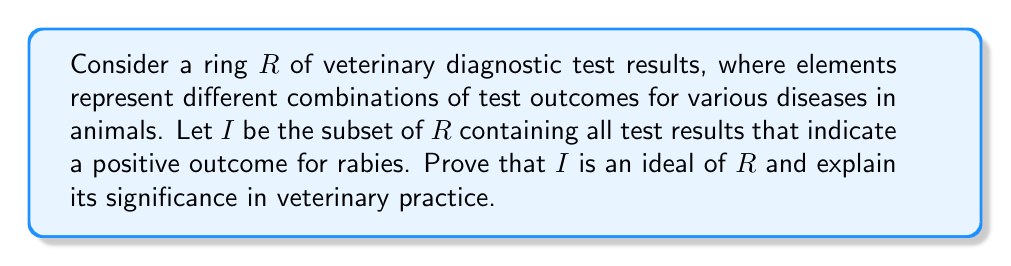What is the answer to this math problem? To prove that $I$ is an ideal of $R$, we need to show that it satisfies three conditions:

1. $I$ is a subgroup of $(R, +)$
2. For all $a \in I$ and $r \in R$, $ra \in I$
3. For all $a \in I$ and $r \in R$, $ar \in I$

Let's examine each condition:

1. $I$ is a subgroup of $(R, +)$:
   - Closure: If $a, b \in I$, then $a + b \in I$ because combining two positive rabies test results still indicates a positive rabies outcome.
   - Identity: The zero element (all negative test results) is in $I$.
   - Inverse: If $a \in I$, then $-a \in I$ because negating a positive rabies result doesn't change its rabies-positive status.

2. For all $a \in I$ and $r \in R$, $ra \in I$:
   This holds because multiplying a rabies-positive result by any other test result combination will still indicate a positive rabies outcome.

3. For all $a \in I$ and $r \in R$, $ar \in I$:
   This is similar to condition 2, as multiplication in this ring is commutative.

Therefore, $I$ is an ideal of $R$.

Significance in veterinary practice:
The ideal $I$ represents all test result combinations that indicate a positive rabies outcome. This is crucial for veterinarians because:

1. It allows for easy identification of rabies cases regardless of other test results.
2. It helps in isolating and treating rabies cases promptly, which is vital for public health.
3. It facilitates the reporting of rabies cases to health authorities, as required by law in many countries, including France.
4. It aids in implementing proper quarantine procedures for animals suspected of rabies.
5. It helps in advising owners about potential exposure and necessary precautions.

As an alumnus of the École nationale vétérinaire de Lyon, understanding this mathematical structure can help in organizing and interpreting complex diagnostic data, especially in cases involving zoonotic diseases like rabies.
Answer: $I$ is an ideal of $R$, representing all test result combinations indicating a positive rabies outcome, which is significant for efficient diagnosis, treatment, and management of rabies cases in veterinary practice. 